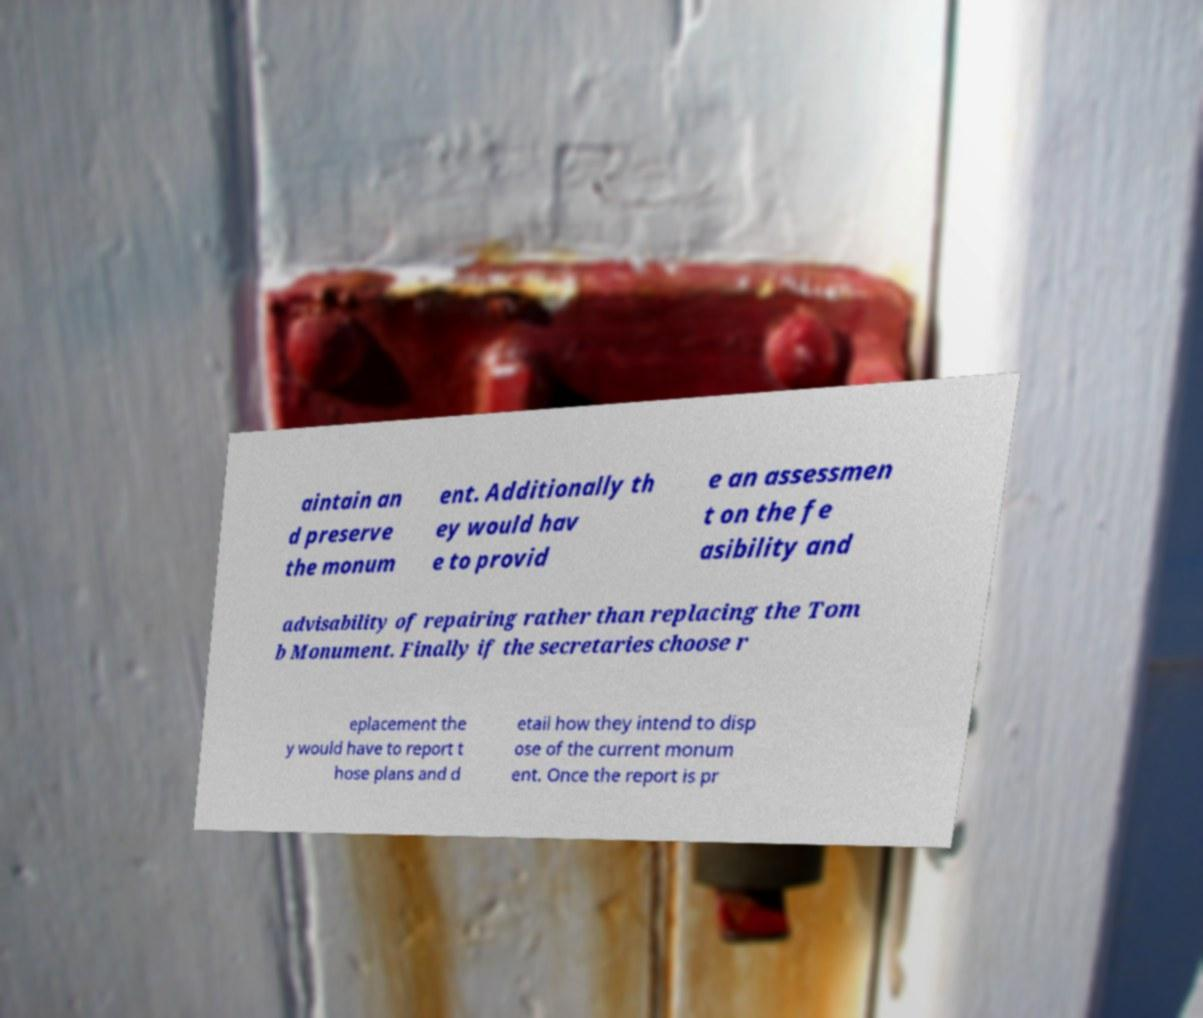Please read and relay the text visible in this image. What does it say? aintain an d preserve the monum ent. Additionally th ey would hav e to provid e an assessmen t on the fe asibility and advisability of repairing rather than replacing the Tom b Monument. Finally if the secretaries choose r eplacement the y would have to report t hose plans and d etail how they intend to disp ose of the current monum ent. Once the report is pr 